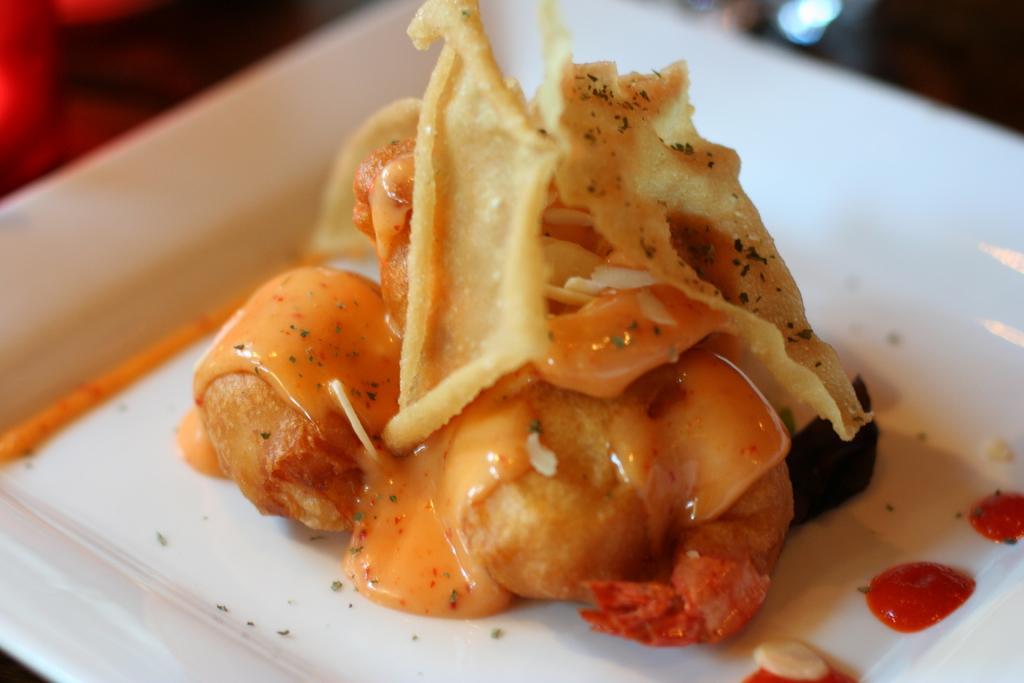What is present on the plate in the image? There is food on the plate in the image. Can you describe the food on the plate? The food on the plate has sauce on it. What type of horse can be seen playing the drum in the image? There is no horse or drum present in the image. Are there any berries visible on the plate in the image? The provided facts do not mention any berries on the plate, so we cannot determine their presence from the image. 